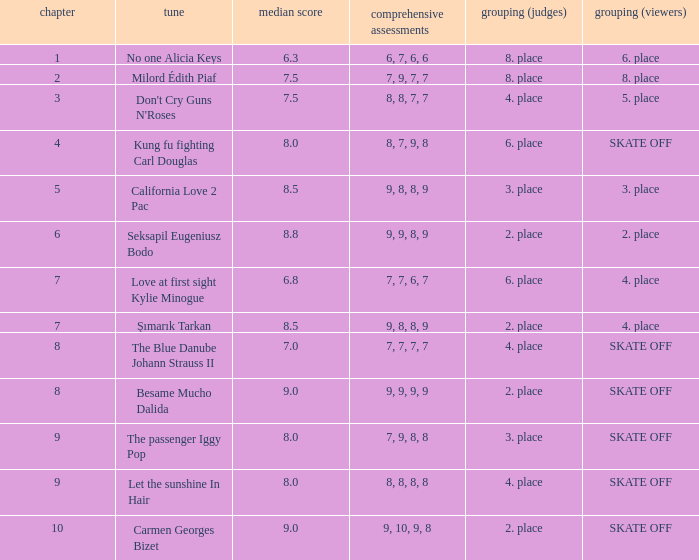Name the average grade for şımarık tarkan 8.5. 